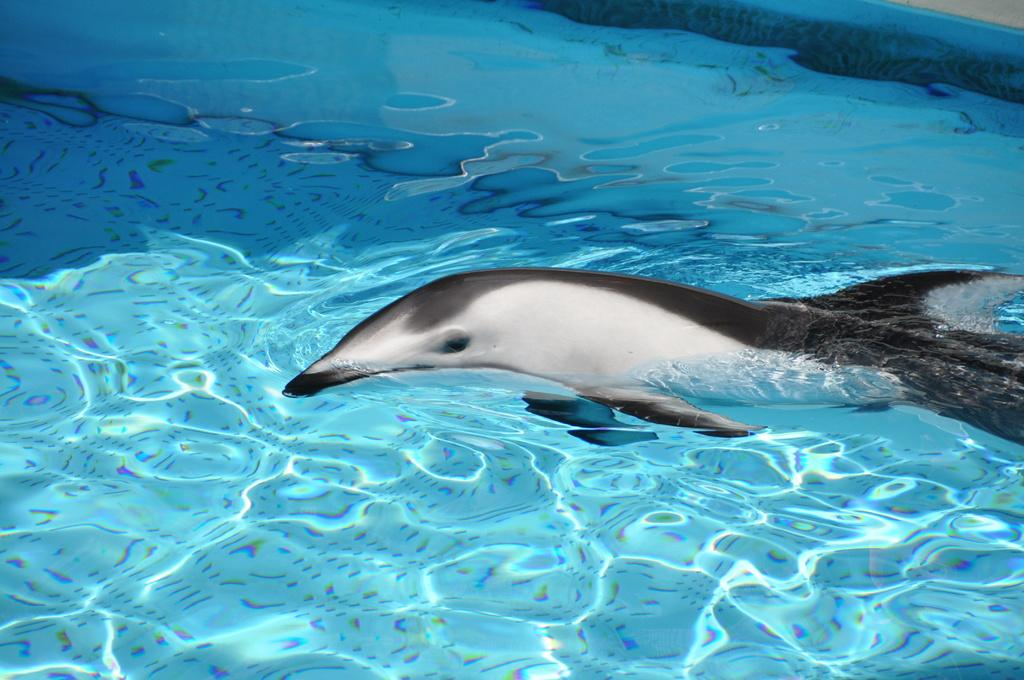What animal is present in the image? There is a dolphin in the image. Where is the dolphin located? The dolphin is in the water. What type of mint can be seen growing near the dolphin in the image? There is no mint present in the image; it features a dolphin in the water. What kind of cakes are being served to the dolphin in the image? There are no cakes present in the image; it features a dolphin in the water. 